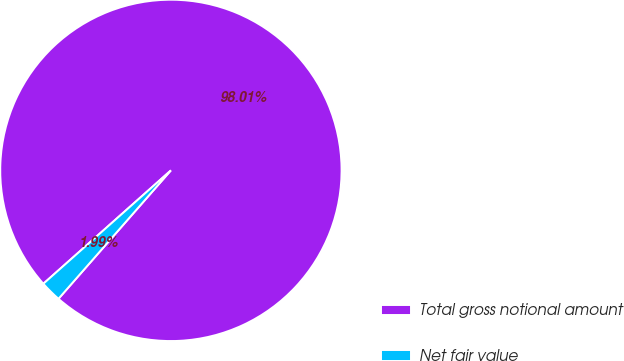Convert chart to OTSL. <chart><loc_0><loc_0><loc_500><loc_500><pie_chart><fcel>Total gross notional amount<fcel>Net fair value<nl><fcel>98.01%<fcel>1.99%<nl></chart> 